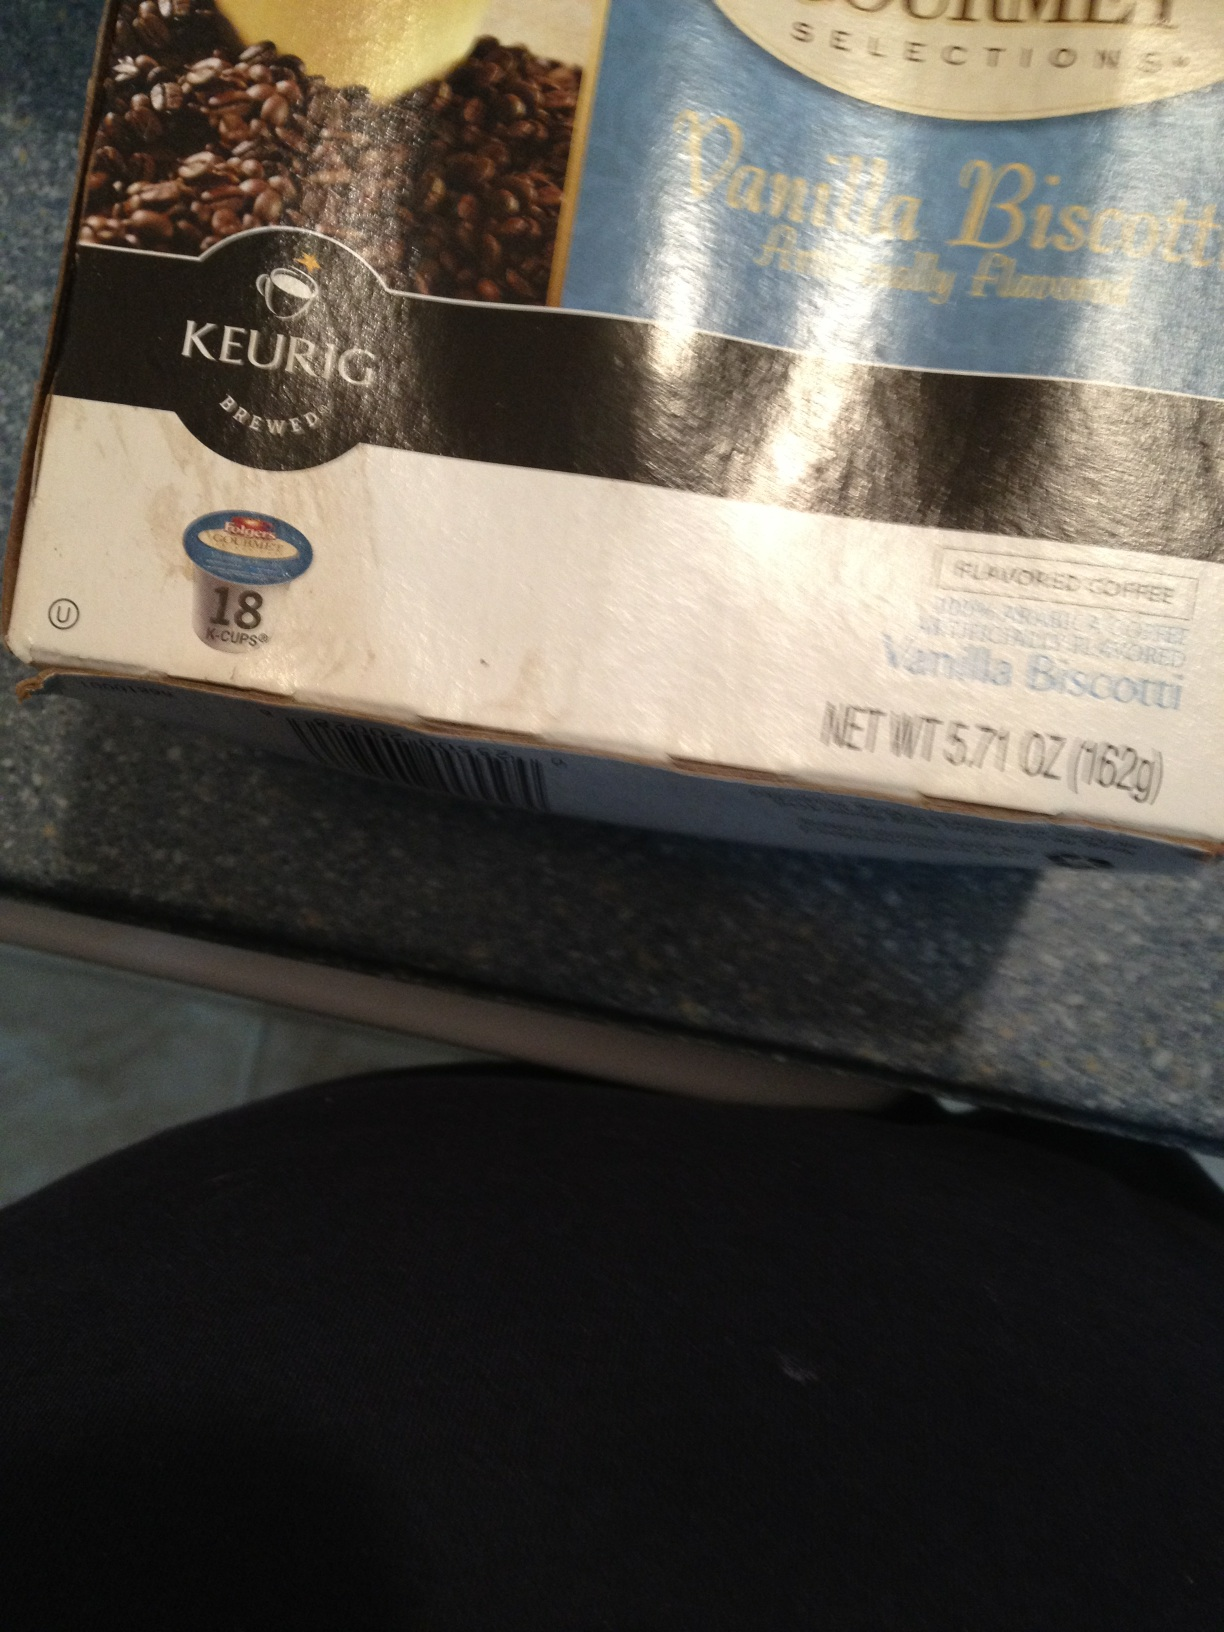Create a dialogue between me and a friend discussing this flavor. Human: Hey, have you tried the new Vanilla Biscotti flavor for the Keurig?
Friend: Oh, I haven’t! What’s it like?
Human: It’s amazing! The flavor is this perfect blend of sweet vanilla and crunchy biscotti. It feels like having a dessert in liquid form.
Friend: That sounds delicious. Is it too sweet?
Human: Not at all. It’s just the right amount of sweetness. Plus, it has that rich coffee aroma that makes it really satisfying.
Friend: I think I’m sold. I’ll definitely give it a try! 